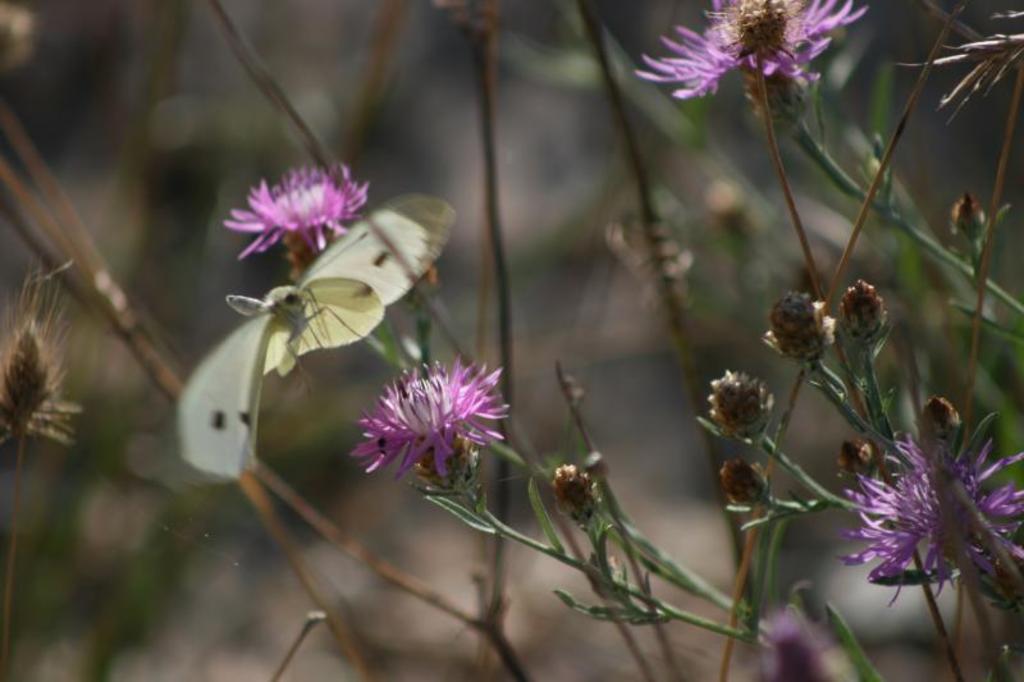Could you give a brief overview of what you see in this image? This image consists of flowers in pink color. And we can see a plant. The background is blurred. 